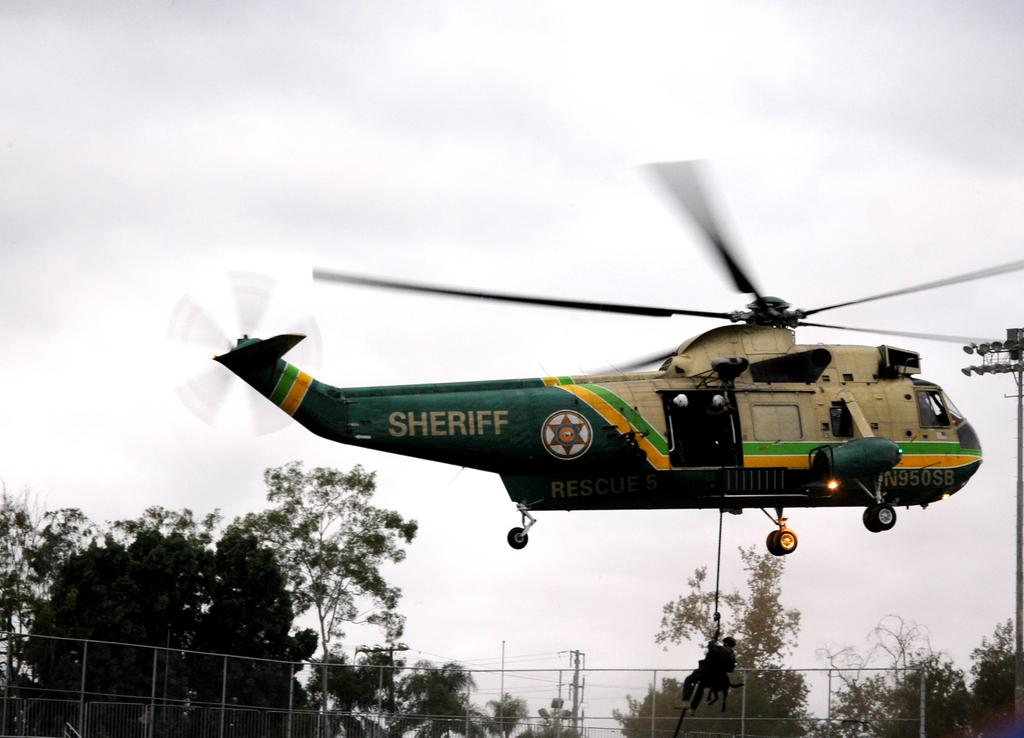<image>
Share a concise interpretation of the image provided. A sheriff helicopter that is flying in the air 